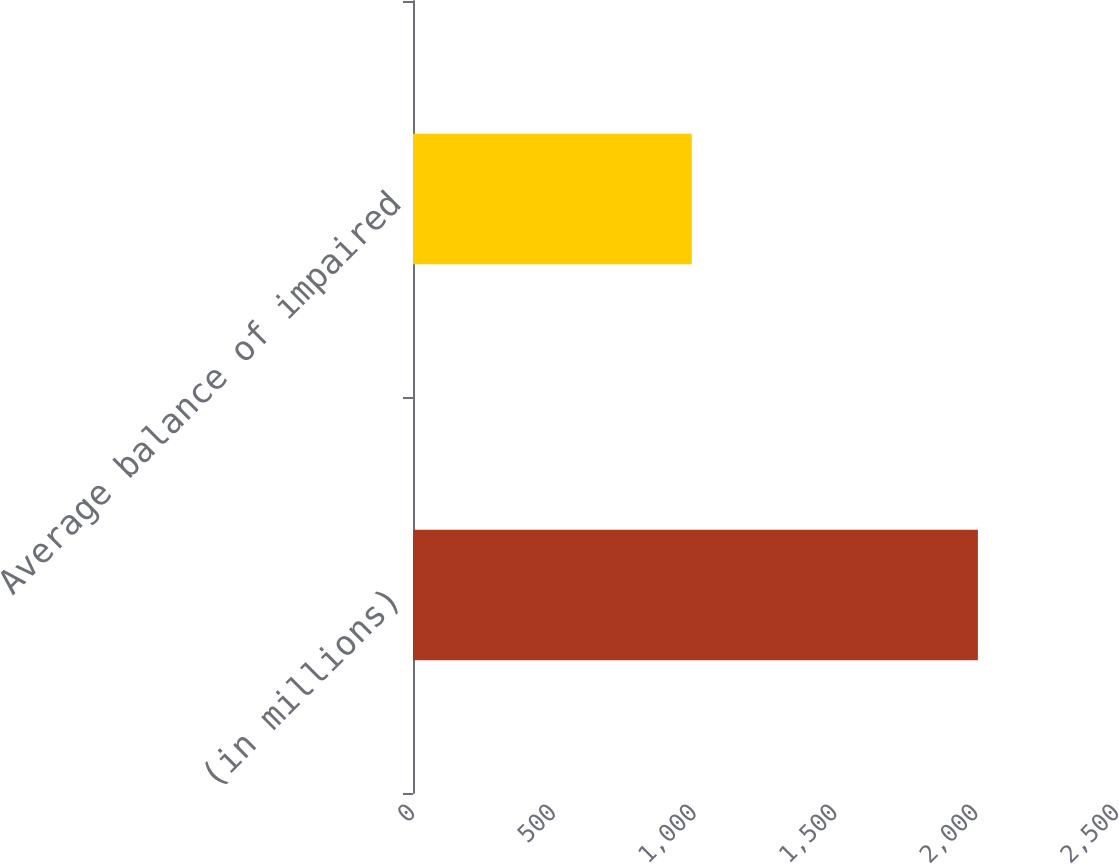<chart> <loc_0><loc_0><loc_500><loc_500><bar_chart><fcel>(in millions)<fcel>Average balance of impaired<nl><fcel>2006<fcel>990<nl></chart> 